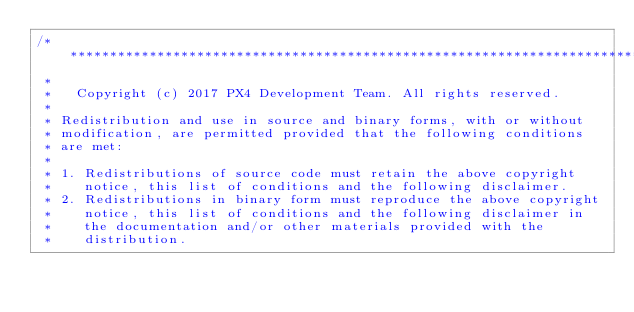Convert code to text. <code><loc_0><loc_0><loc_500><loc_500><_C++_>/****************************************************************************
 *
 *   Copyright (c) 2017 PX4 Development Team. All rights reserved.
 *
 * Redistribution and use in source and binary forms, with or without
 * modification, are permitted provided that the following conditions
 * are met:
 *
 * 1. Redistributions of source code must retain the above copyright
 *    notice, this list of conditions and the following disclaimer.
 * 2. Redistributions in binary form must reproduce the above copyright
 *    notice, this list of conditions and the following disclaimer in
 *    the documentation and/or other materials provided with the
 *    distribution.</code> 